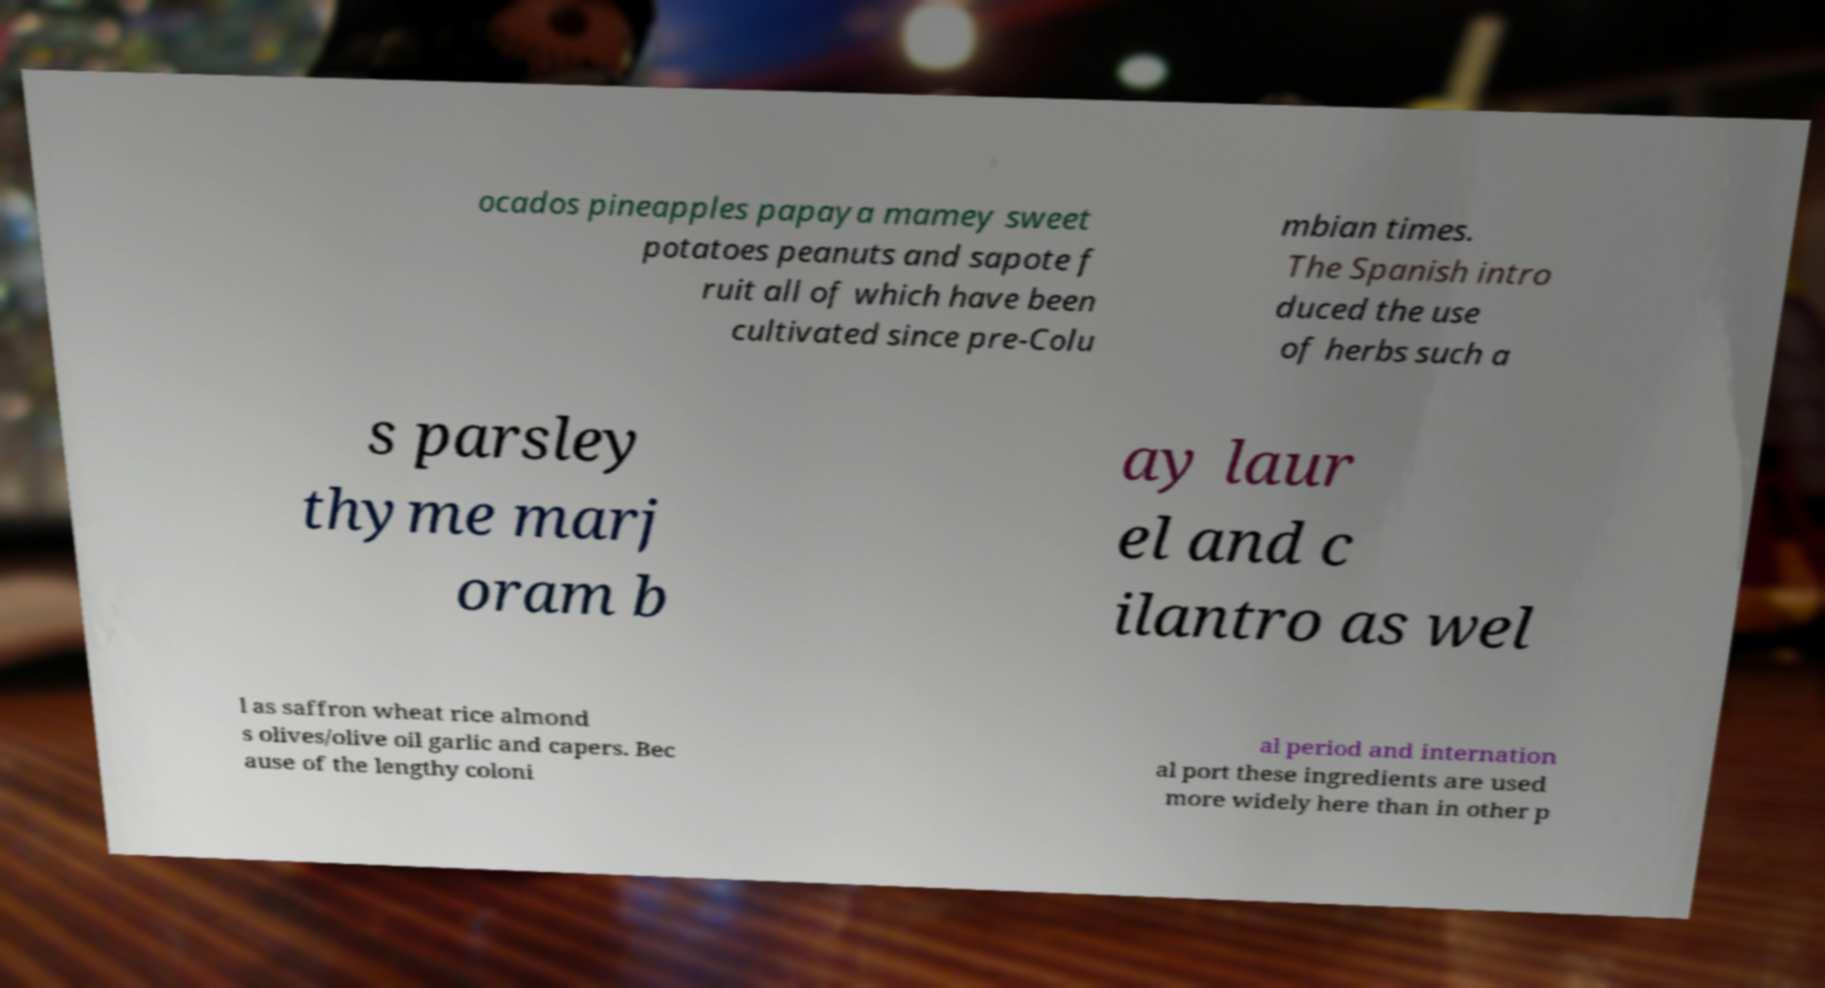I need the written content from this picture converted into text. Can you do that? ocados pineapples papaya mamey sweet potatoes peanuts and sapote f ruit all of which have been cultivated since pre-Colu mbian times. The Spanish intro duced the use of herbs such a s parsley thyme marj oram b ay laur el and c ilantro as wel l as saffron wheat rice almond s olives/olive oil garlic and capers. Bec ause of the lengthy coloni al period and internation al port these ingredients are used more widely here than in other p 